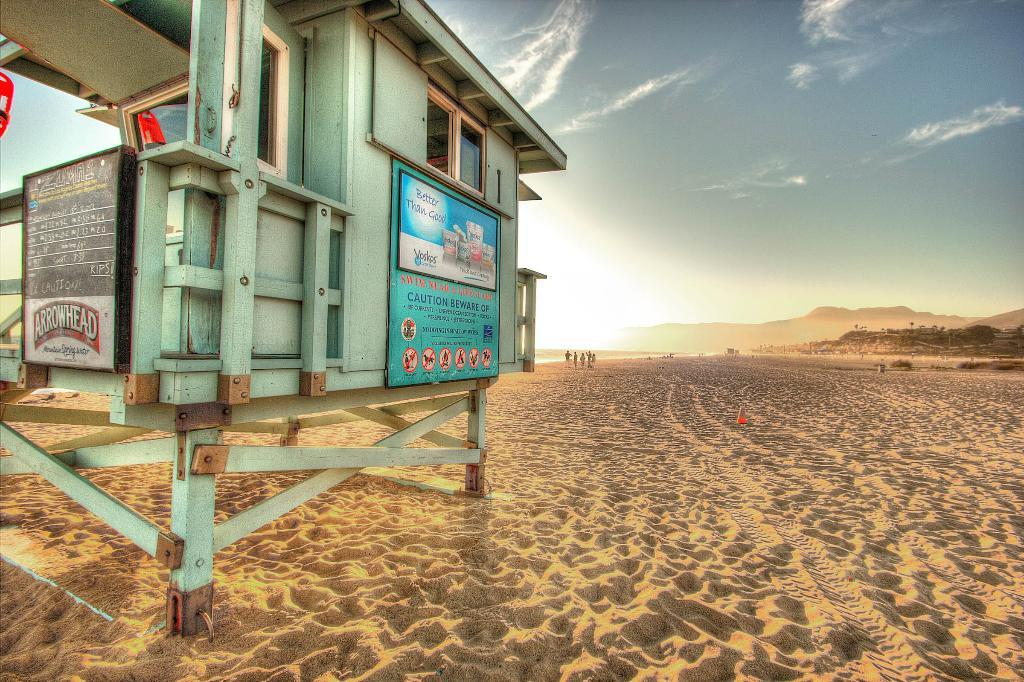What is located on the left side of the image? There is a signage on the left side of the image. What can be seen in the background of the image? There are people in the background of the image. Can you describe the setting of the image? The image appears to depict a desert setting. What type of celery can be seen growing in the desert in the image? There is no celery present in the image, and celery does not typically grow in desert settings. 